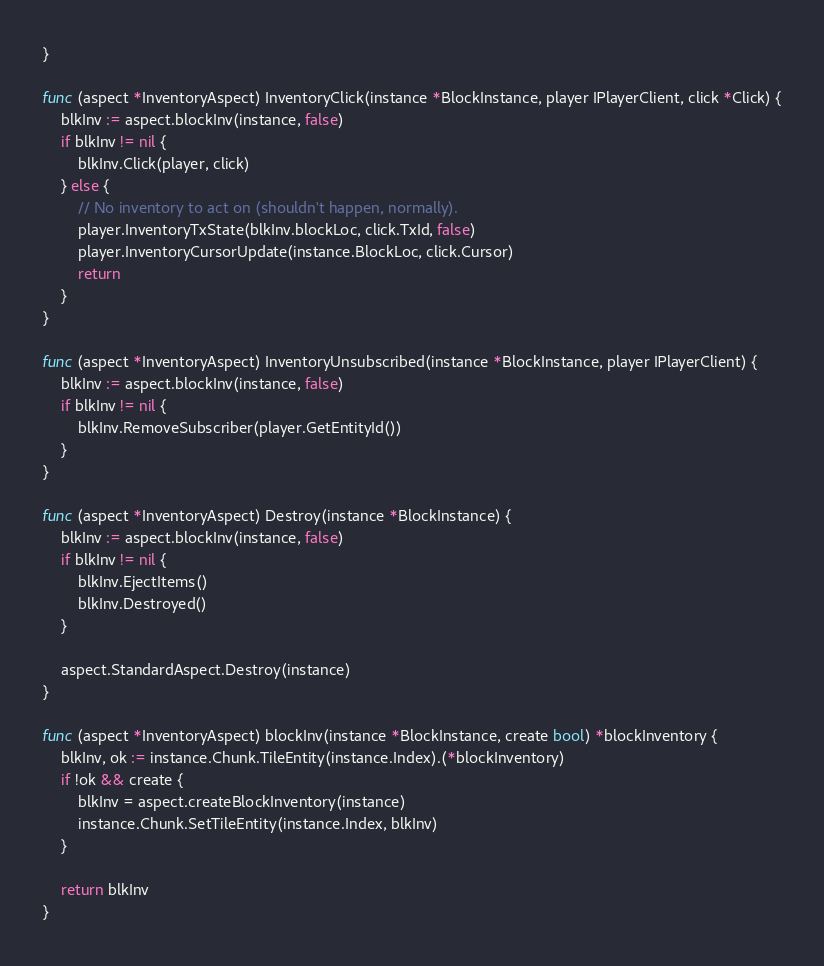<code> <loc_0><loc_0><loc_500><loc_500><_Go_>}

func (aspect *InventoryAspect) InventoryClick(instance *BlockInstance, player IPlayerClient, click *Click) {
	blkInv := aspect.blockInv(instance, false)
	if blkInv != nil {
		blkInv.Click(player, click)
	} else {
		// No inventory to act on (shouldn't happen, normally).
		player.InventoryTxState(blkInv.blockLoc, click.TxId, false)
		player.InventoryCursorUpdate(instance.BlockLoc, click.Cursor)
		return
	}
}

func (aspect *InventoryAspect) InventoryUnsubscribed(instance *BlockInstance, player IPlayerClient) {
	blkInv := aspect.blockInv(instance, false)
	if blkInv != nil {
		blkInv.RemoveSubscriber(player.GetEntityId())
	}
}

func (aspect *InventoryAspect) Destroy(instance *BlockInstance) {
	blkInv := aspect.blockInv(instance, false)
	if blkInv != nil {
		blkInv.EjectItems()
		blkInv.Destroyed()
	}

	aspect.StandardAspect.Destroy(instance)
}

func (aspect *InventoryAspect) blockInv(instance *BlockInstance, create bool) *blockInventory {
	blkInv, ok := instance.Chunk.TileEntity(instance.Index).(*blockInventory)
	if !ok && create {
		blkInv = aspect.createBlockInventory(instance)
		instance.Chunk.SetTileEntity(instance.Index, blkInv)
	}

	return blkInv
}
</code> 